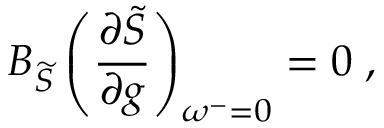Convert formula to latex. <formula><loc_0><loc_0><loc_500><loc_500>B _ { \widetilde { S } } \left ( \frac { \partial \widetilde { S } } { \partial g } \right ) _ { \omega ^ { - } = 0 } = 0 \, ,</formula> 